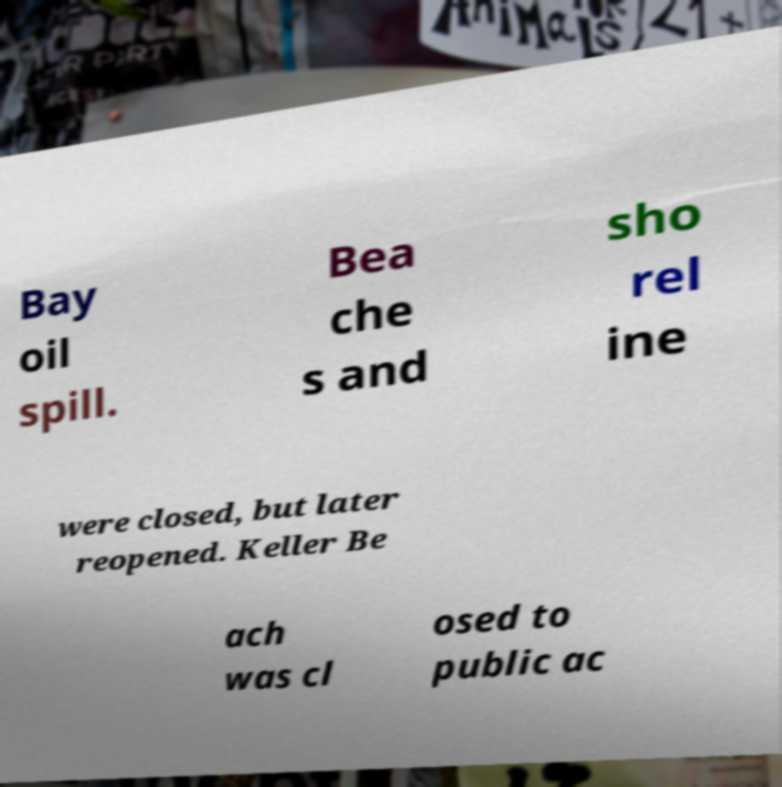Could you extract and type out the text from this image? Bay oil spill. Bea che s and sho rel ine were closed, but later reopened. Keller Be ach was cl osed to public ac 